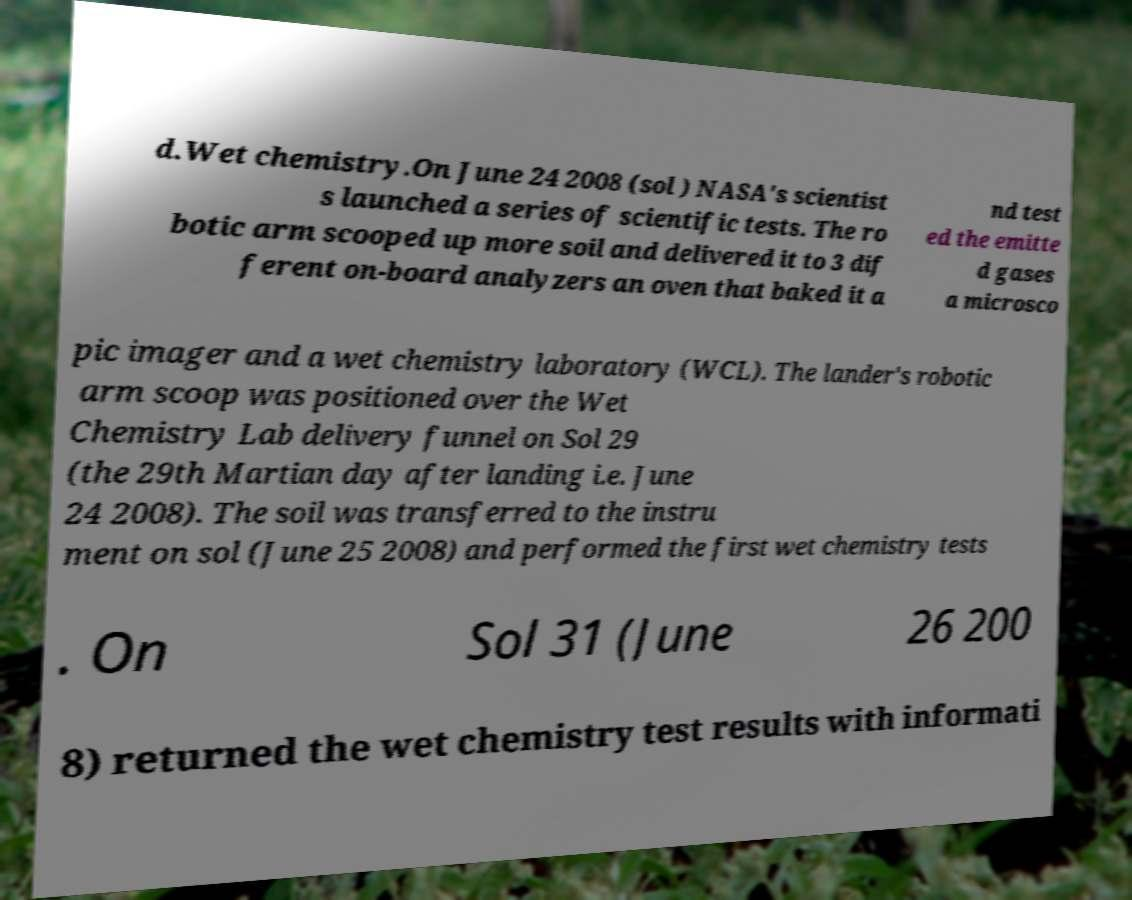For documentation purposes, I need the text within this image transcribed. Could you provide that? d.Wet chemistry.On June 24 2008 (sol ) NASA's scientist s launched a series of scientific tests. The ro botic arm scooped up more soil and delivered it to 3 dif ferent on-board analyzers an oven that baked it a nd test ed the emitte d gases a microsco pic imager and a wet chemistry laboratory (WCL). The lander's robotic arm scoop was positioned over the Wet Chemistry Lab delivery funnel on Sol 29 (the 29th Martian day after landing i.e. June 24 2008). The soil was transferred to the instru ment on sol (June 25 2008) and performed the first wet chemistry tests . On Sol 31 (June 26 200 8) returned the wet chemistry test results with informati 